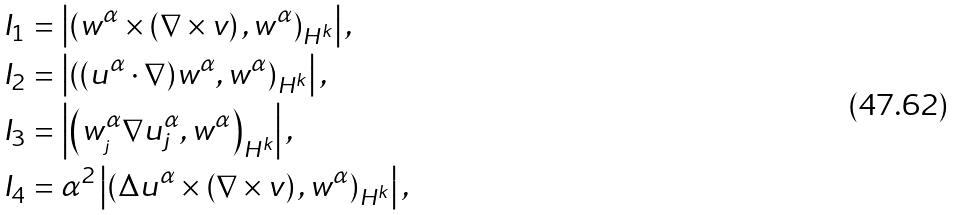<formula> <loc_0><loc_0><loc_500><loc_500>I _ { 1 } & = \left | \left ( w ^ { \alpha } \times \left ( \nabla \times v \right ) , w ^ { \alpha } \right ) _ { H ^ { k } } \right | , \\ I _ { 2 } & = \left | \left ( ( { u } ^ { \alpha } \cdot \nabla ) w ^ { \alpha } , w ^ { \alpha } \right ) _ { H ^ { k } } \right | , \\ I _ { 3 } & = \left | \left ( w _ { _ { j } } ^ { \alpha } \nabla { u } _ { j } ^ { \alpha } , w ^ { \alpha } \right ) _ { H ^ { k } } \right | , \\ I _ { 4 } & = \alpha ^ { 2 } \left | \left ( \Delta { u } ^ { \alpha } \times \left ( \nabla \times v \right ) , w ^ { \alpha } \right ) _ { H ^ { k } } \right | ,</formula> 